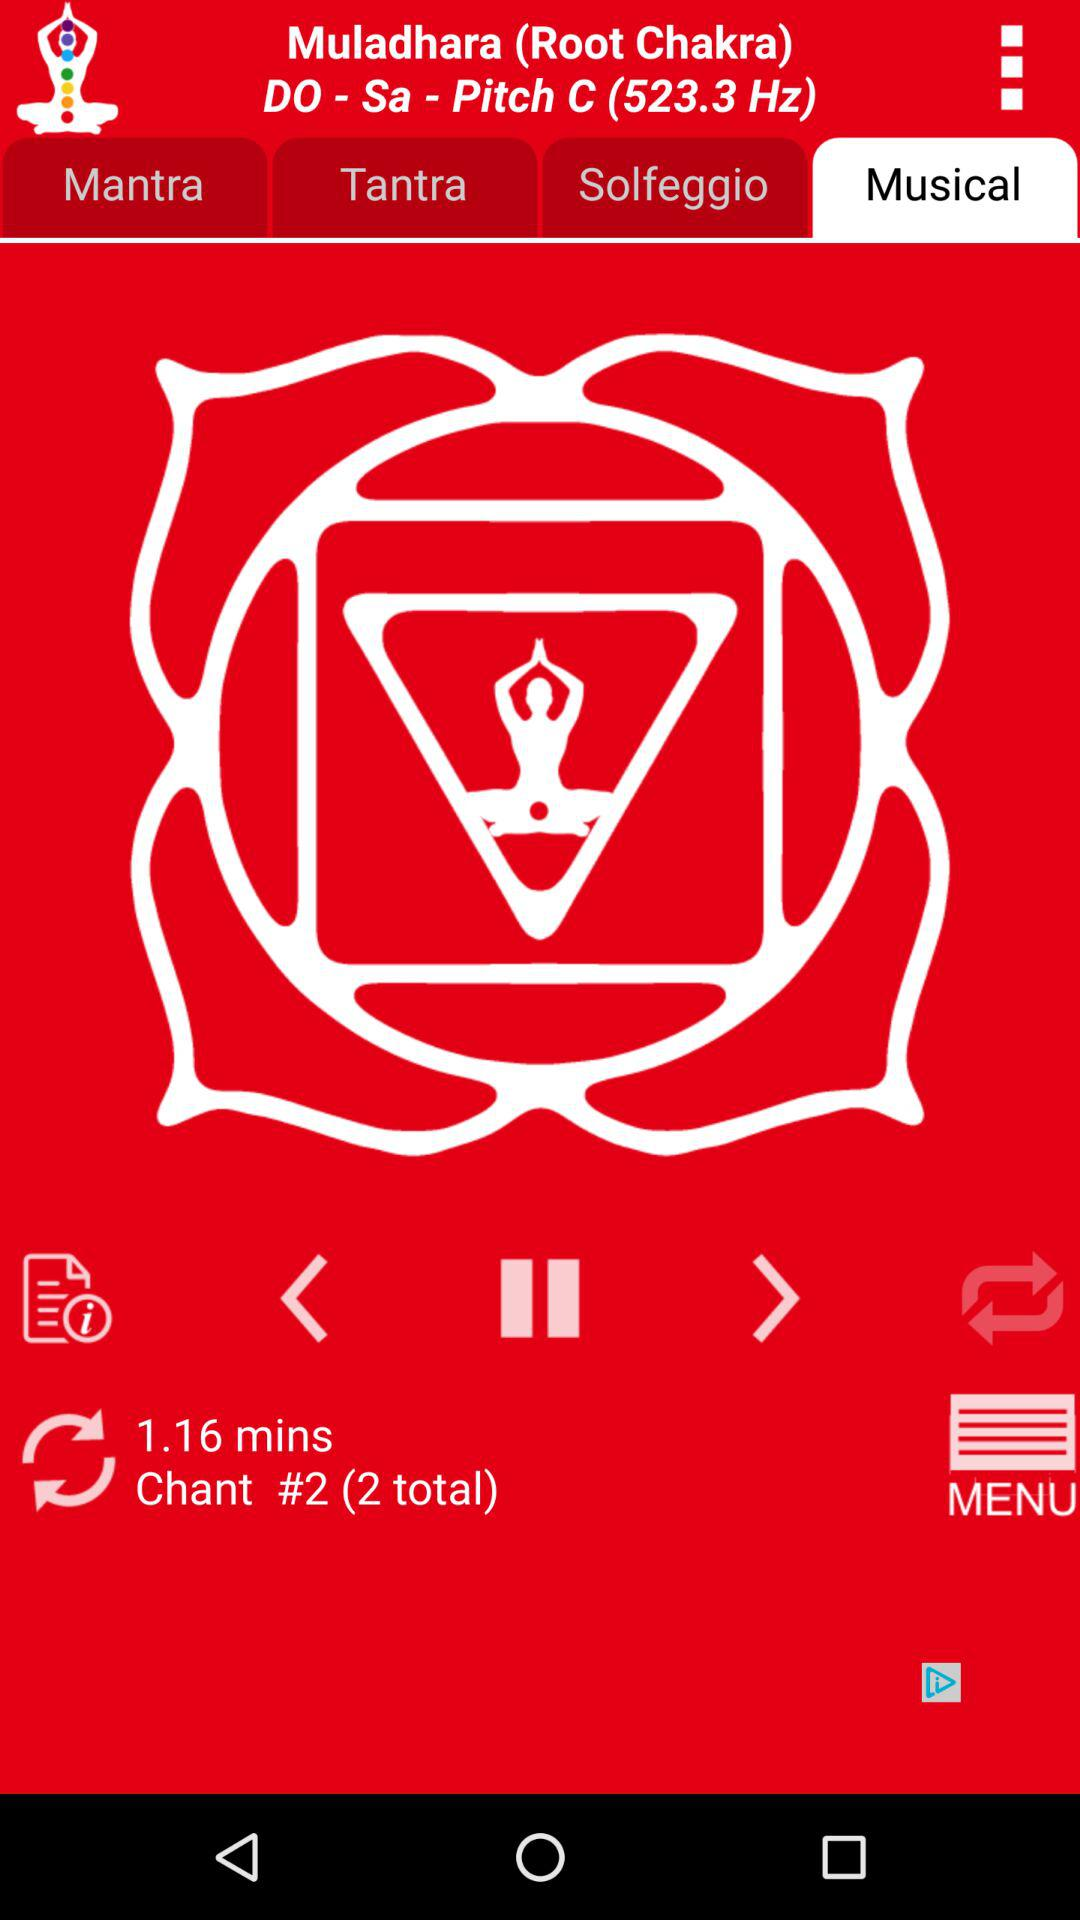What is the duration of the mantra? The duration of the mantra is 1 minute 16 seconds. 